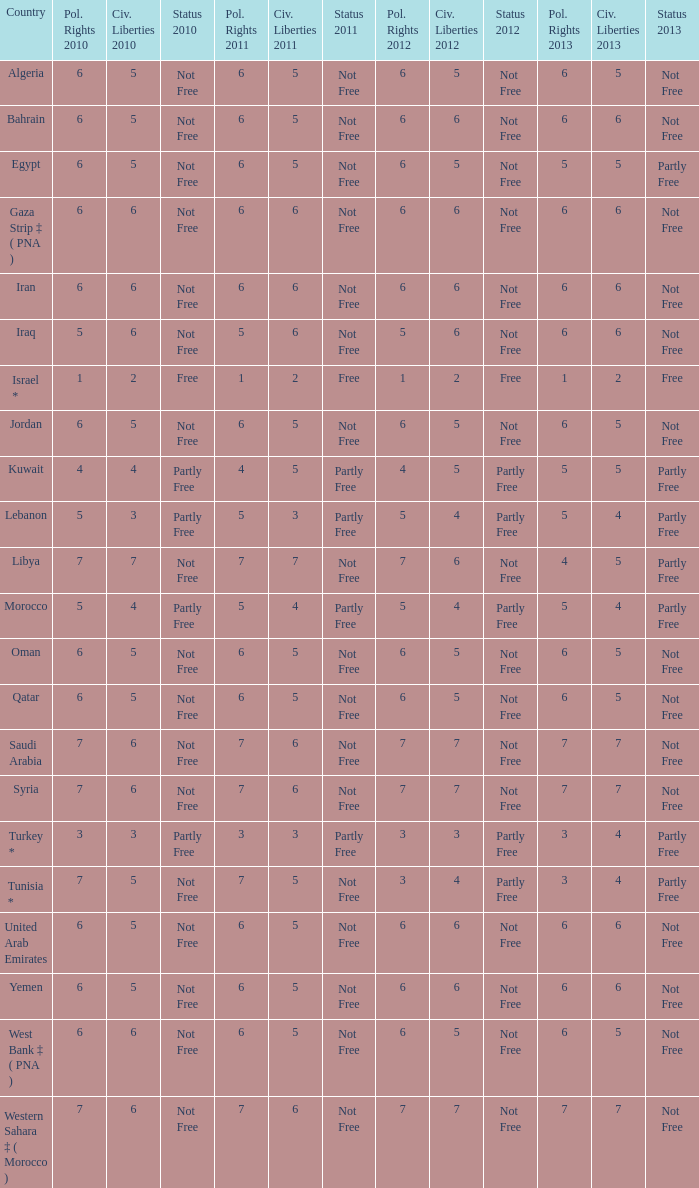How many civil liberties 2013 values are associated with a 2010 political rights value of 6, civil liberties 2012 values over 5, and political rights 2011 under 6? 0.0. 